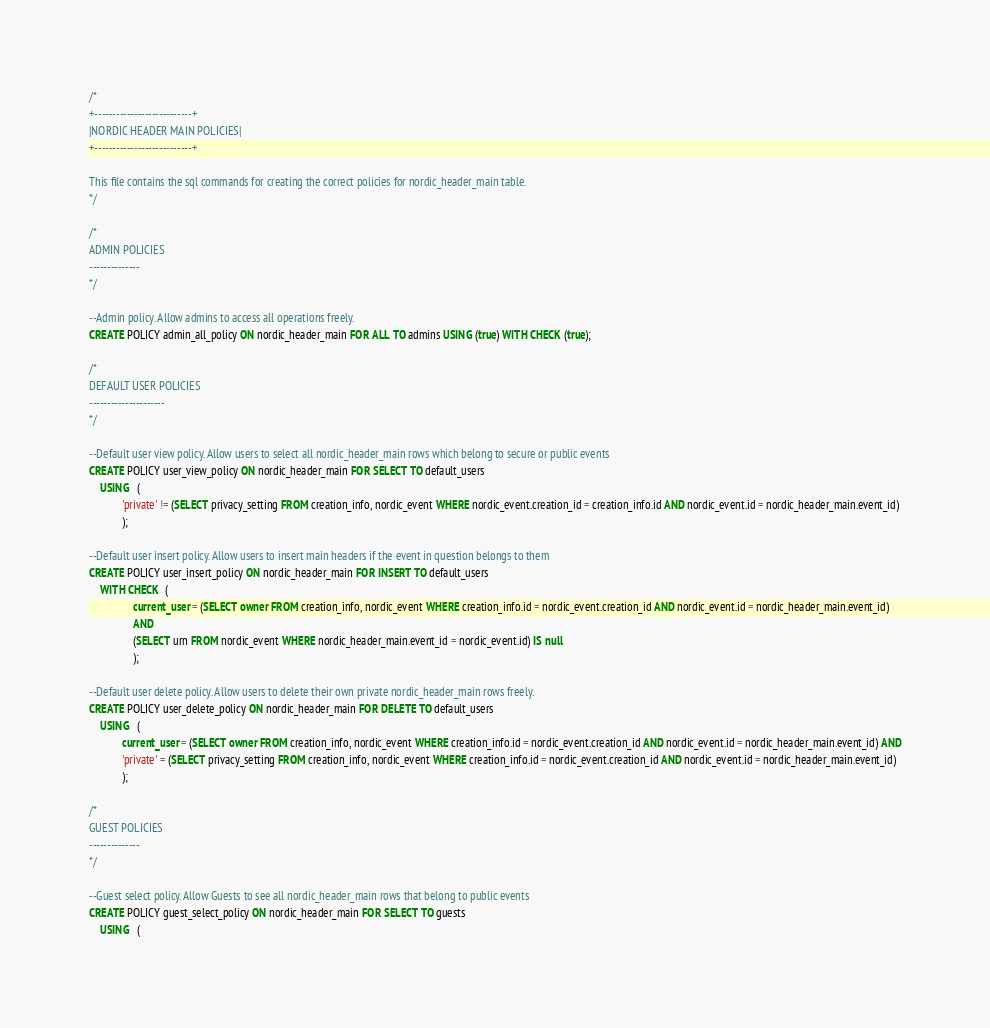Convert code to text. <code><loc_0><loc_0><loc_500><loc_500><_SQL_>/*
+---------------------------+
|NORDIC HEADER MAIN POLICIES|
+---------------------------+

This file contains the sql commands for creating the correct policies for nordic_header_main table.
*/

/*
ADMIN POLICIES
--------------
*/

--Admin policy. Allow admins to access all operations freely.
CREATE POLICY admin_all_policy ON nordic_header_main FOR ALL TO admins USING (true) WITH CHECK (true);

/*
DEFAULT USER POLICIES
---------------------
*/

--Default user view policy. Allow users to select all nordic_header_main rows which belong to secure or public events
CREATE POLICY user_view_policy ON nordic_header_main FOR SELECT TO default_users 
    USING   (
            'private' != (SELECT privacy_setting FROM creation_info, nordic_event WHERE nordic_event.creation_id = creation_info.id AND nordic_event.id = nordic_header_main.event_id)
            );

--Default user insert policy. Allow users to insert main headers if the event in question belongs to them
CREATE POLICY user_insert_policy ON nordic_header_main FOR INSERT TO default_users 
    WITH CHECK  (
                current_user = (SELECT owner FROM creation_info, nordic_event WHERE creation_info.id = nordic_event.creation_id AND nordic_event.id = nordic_header_main.event_id)
                AND
                (SELECT urn FROM nordic_event WHERE nordic_header_main.event_id = nordic_event.id) IS null
                );

--Default user delete policy. Allow users to delete their own private nordic_header_main rows freely.
CREATE POLICY user_delete_policy ON nordic_header_main FOR DELETE TO default_users 
    USING   (
            current_user = (SELECT owner FROM creation_info, nordic_event WHERE creation_info.id = nordic_event.creation_id AND nordic_event.id = nordic_header_main.event_id) AND
            'private' = (SELECT privacy_setting FROM creation_info, nordic_event WHERE creation_info.id = nordic_event.creation_id AND nordic_event.id = nordic_header_main.event_id)
            );

/*
GUEST POLICIES
--------------
*/

--Guest select policy. Allow Guests to see all nordic_header_main rows that belong to public events 
CREATE POLICY guest_select_policy ON nordic_header_main FOR SELECT TO guests
    USING   (</code> 